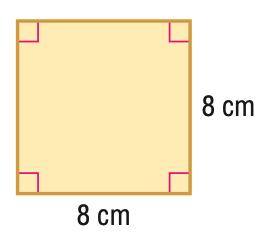Answer the mathemtical geometry problem and directly provide the correct option letter.
Question: Find the area of the figure.
Choices: A: 16 B: 32 C: 64 D: 128 C 